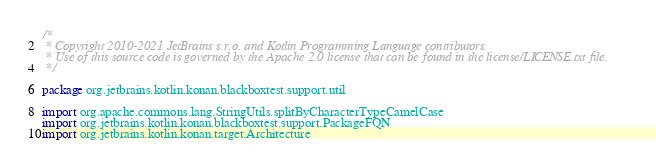<code> <loc_0><loc_0><loc_500><loc_500><_Kotlin_>/*
 * Copyright 2010-2021 JetBrains s.r.o. and Kotlin Programming Language contributors.
 * Use of this source code is governed by the Apache 2.0 license that can be found in the license/LICENSE.txt file.
 */

package org.jetbrains.kotlin.konan.blackboxtest.support.util

import org.apache.commons.lang.StringUtils.splitByCharacterTypeCamelCase
import org.jetbrains.kotlin.konan.blackboxtest.support.PackageFQN
import org.jetbrains.kotlin.konan.target.Architecture</code> 